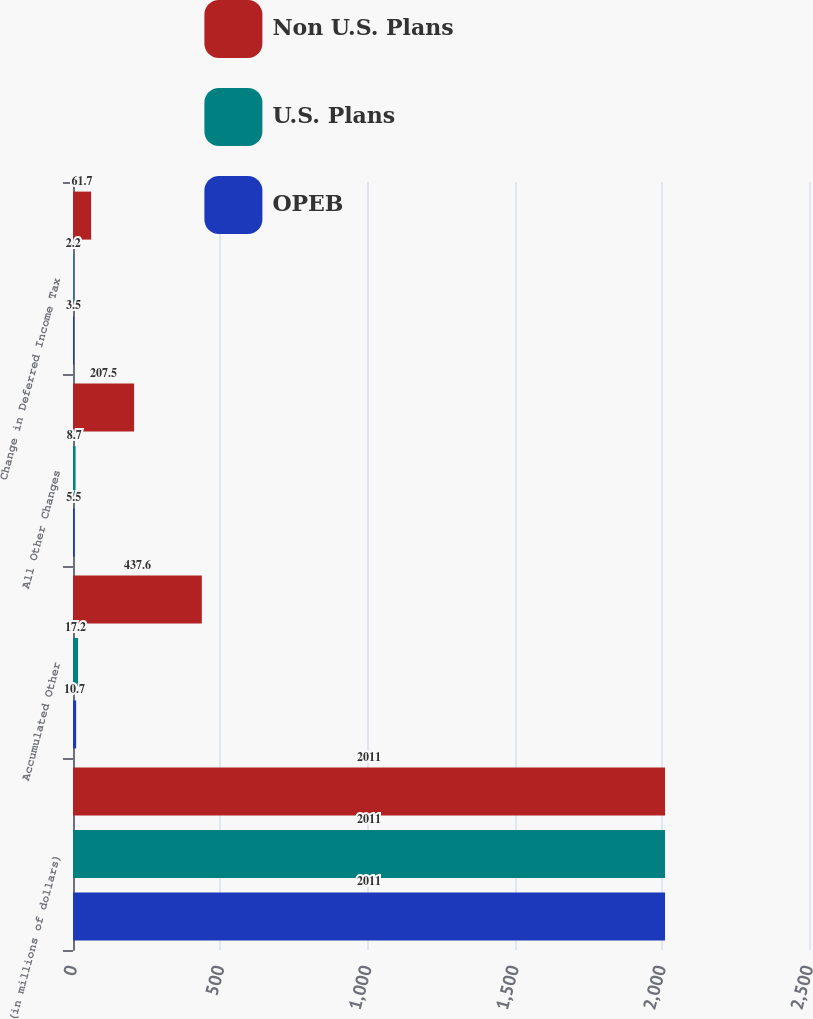Convert chart. <chart><loc_0><loc_0><loc_500><loc_500><stacked_bar_chart><ecel><fcel>(in millions of dollars)<fcel>Accumulated Other<fcel>All Other Changes<fcel>Change in Deferred Income Tax<nl><fcel>Non U.S. Plans<fcel>2011<fcel>437.6<fcel>207.5<fcel>61.7<nl><fcel>U.S. Plans<fcel>2011<fcel>17.2<fcel>8.7<fcel>2.2<nl><fcel>OPEB<fcel>2011<fcel>10.7<fcel>5.5<fcel>3.5<nl></chart> 